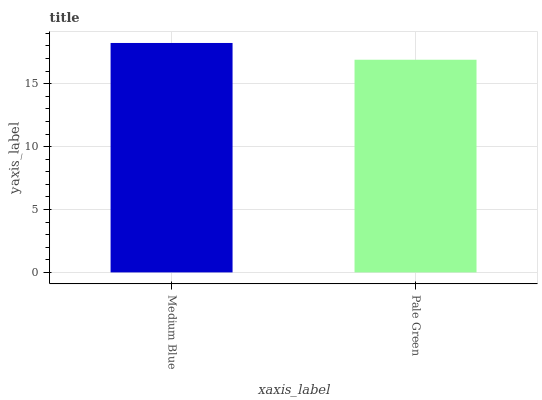Is Pale Green the minimum?
Answer yes or no. Yes. Is Medium Blue the maximum?
Answer yes or no. Yes. Is Pale Green the maximum?
Answer yes or no. No. Is Medium Blue greater than Pale Green?
Answer yes or no. Yes. Is Pale Green less than Medium Blue?
Answer yes or no. Yes. Is Pale Green greater than Medium Blue?
Answer yes or no. No. Is Medium Blue less than Pale Green?
Answer yes or no. No. Is Medium Blue the high median?
Answer yes or no. Yes. Is Pale Green the low median?
Answer yes or no. Yes. Is Pale Green the high median?
Answer yes or no. No. Is Medium Blue the low median?
Answer yes or no. No. 